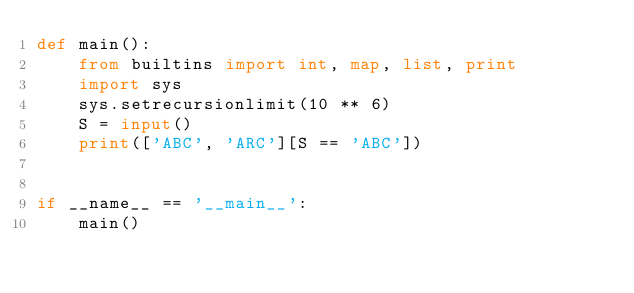<code> <loc_0><loc_0><loc_500><loc_500><_Python_>def main():
    from builtins import int, map, list, print
    import sys
    sys.setrecursionlimit(10 ** 6)
    S = input()
    print(['ABC', 'ARC'][S == 'ABC'])


if __name__ == '__main__':
    main()
</code> 